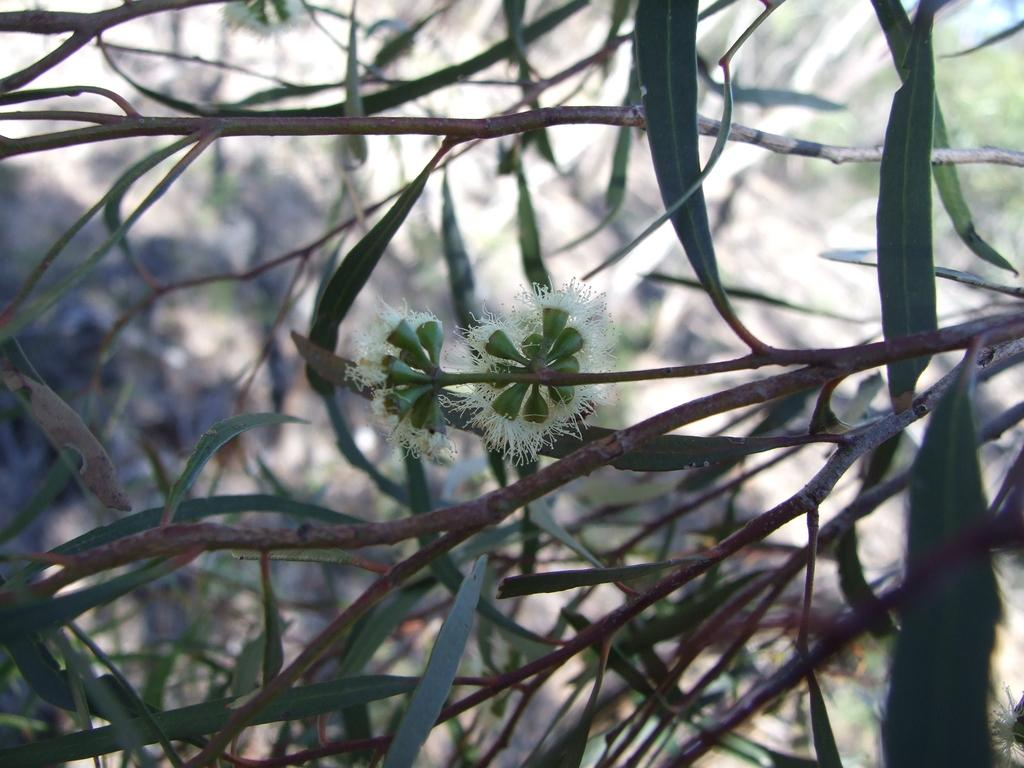What is the main subject of the image? The main subject of the image is a tree. Can you describe any specific features of the tree? The image is a zoomed-in view of the tree, so we can see details of the tree's branches and leaves. What else can be seen in the image besides the tree? There are two flowers in the middle of the image. What type of arch can be seen in the background of the image? There is no arch present in the image; it is a close-up view of a tree with two flowers in the middle. 